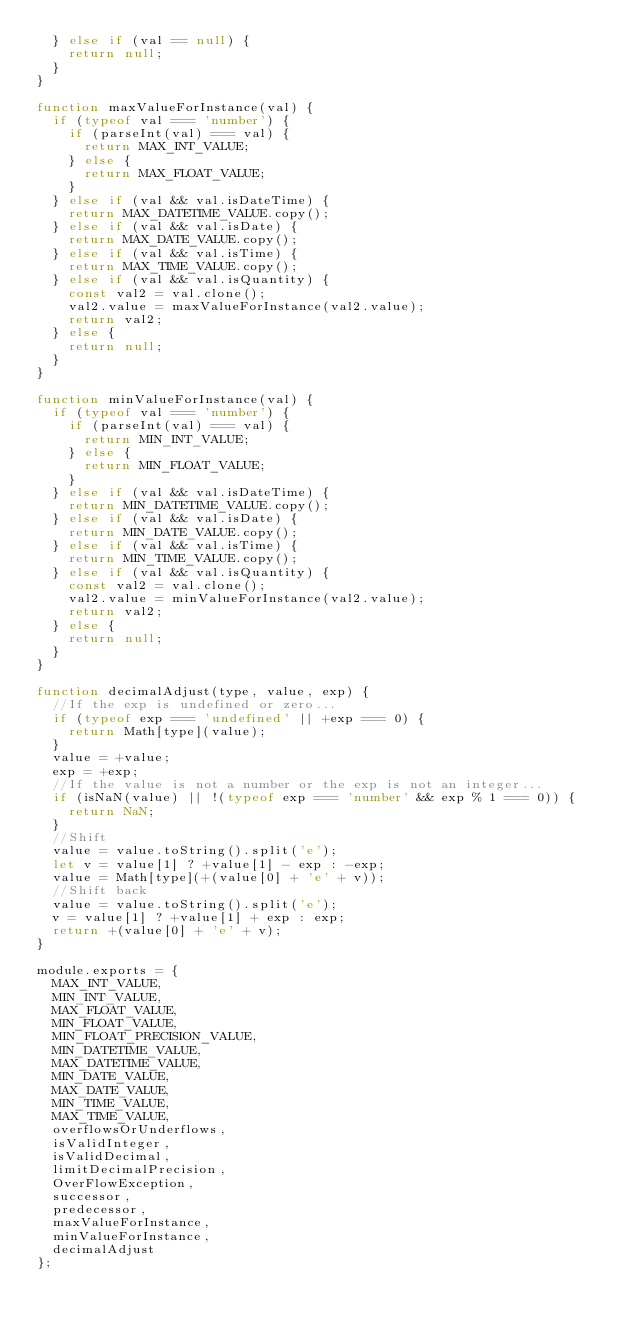Convert code to text. <code><loc_0><loc_0><loc_500><loc_500><_JavaScript_>  } else if (val == null) {
    return null;
  }
}

function maxValueForInstance(val) {
  if (typeof val === 'number') {
    if (parseInt(val) === val) {
      return MAX_INT_VALUE;
    } else {
      return MAX_FLOAT_VALUE;
    }
  } else if (val && val.isDateTime) {
    return MAX_DATETIME_VALUE.copy();
  } else if (val && val.isDate) {
    return MAX_DATE_VALUE.copy();
  } else if (val && val.isTime) {
    return MAX_TIME_VALUE.copy();
  } else if (val && val.isQuantity) {
    const val2 = val.clone();
    val2.value = maxValueForInstance(val2.value);
    return val2;
  } else {
    return null;
  }
}

function minValueForInstance(val) {
  if (typeof val === 'number') {
    if (parseInt(val) === val) {
      return MIN_INT_VALUE;
    } else {
      return MIN_FLOAT_VALUE;
    }
  } else if (val && val.isDateTime) {
    return MIN_DATETIME_VALUE.copy();
  } else if (val && val.isDate) {
    return MIN_DATE_VALUE.copy();
  } else if (val && val.isTime) {
    return MIN_TIME_VALUE.copy();
  } else if (val && val.isQuantity) {
    const val2 = val.clone();
    val2.value = minValueForInstance(val2.value);
    return val2;
  } else {
    return null;
  }
}

function decimalAdjust(type, value, exp) {
  //If the exp is undefined or zero...
  if (typeof exp === 'undefined' || +exp === 0) {
    return Math[type](value);
  }
  value = +value;
  exp = +exp;
  //If the value is not a number or the exp is not an integer...
  if (isNaN(value) || !(typeof exp === 'number' && exp % 1 === 0)) {
    return NaN;
  }
  //Shift
  value = value.toString().split('e');
  let v = value[1] ? +value[1] - exp : -exp;
  value = Math[type](+(value[0] + 'e' + v));
  //Shift back
  value = value.toString().split('e');
  v = value[1] ? +value[1] + exp : exp;
  return +(value[0] + 'e' + v);
}

module.exports = {
  MAX_INT_VALUE,
  MIN_INT_VALUE,
  MAX_FLOAT_VALUE,
  MIN_FLOAT_VALUE,
  MIN_FLOAT_PRECISION_VALUE,
  MIN_DATETIME_VALUE,
  MAX_DATETIME_VALUE,
  MIN_DATE_VALUE,
  MAX_DATE_VALUE,
  MIN_TIME_VALUE,
  MAX_TIME_VALUE,
  overflowsOrUnderflows,
  isValidInteger,
  isValidDecimal,
  limitDecimalPrecision,
  OverFlowException,
  successor,
  predecessor,
  maxValueForInstance,
  minValueForInstance,
  decimalAdjust
};
</code> 